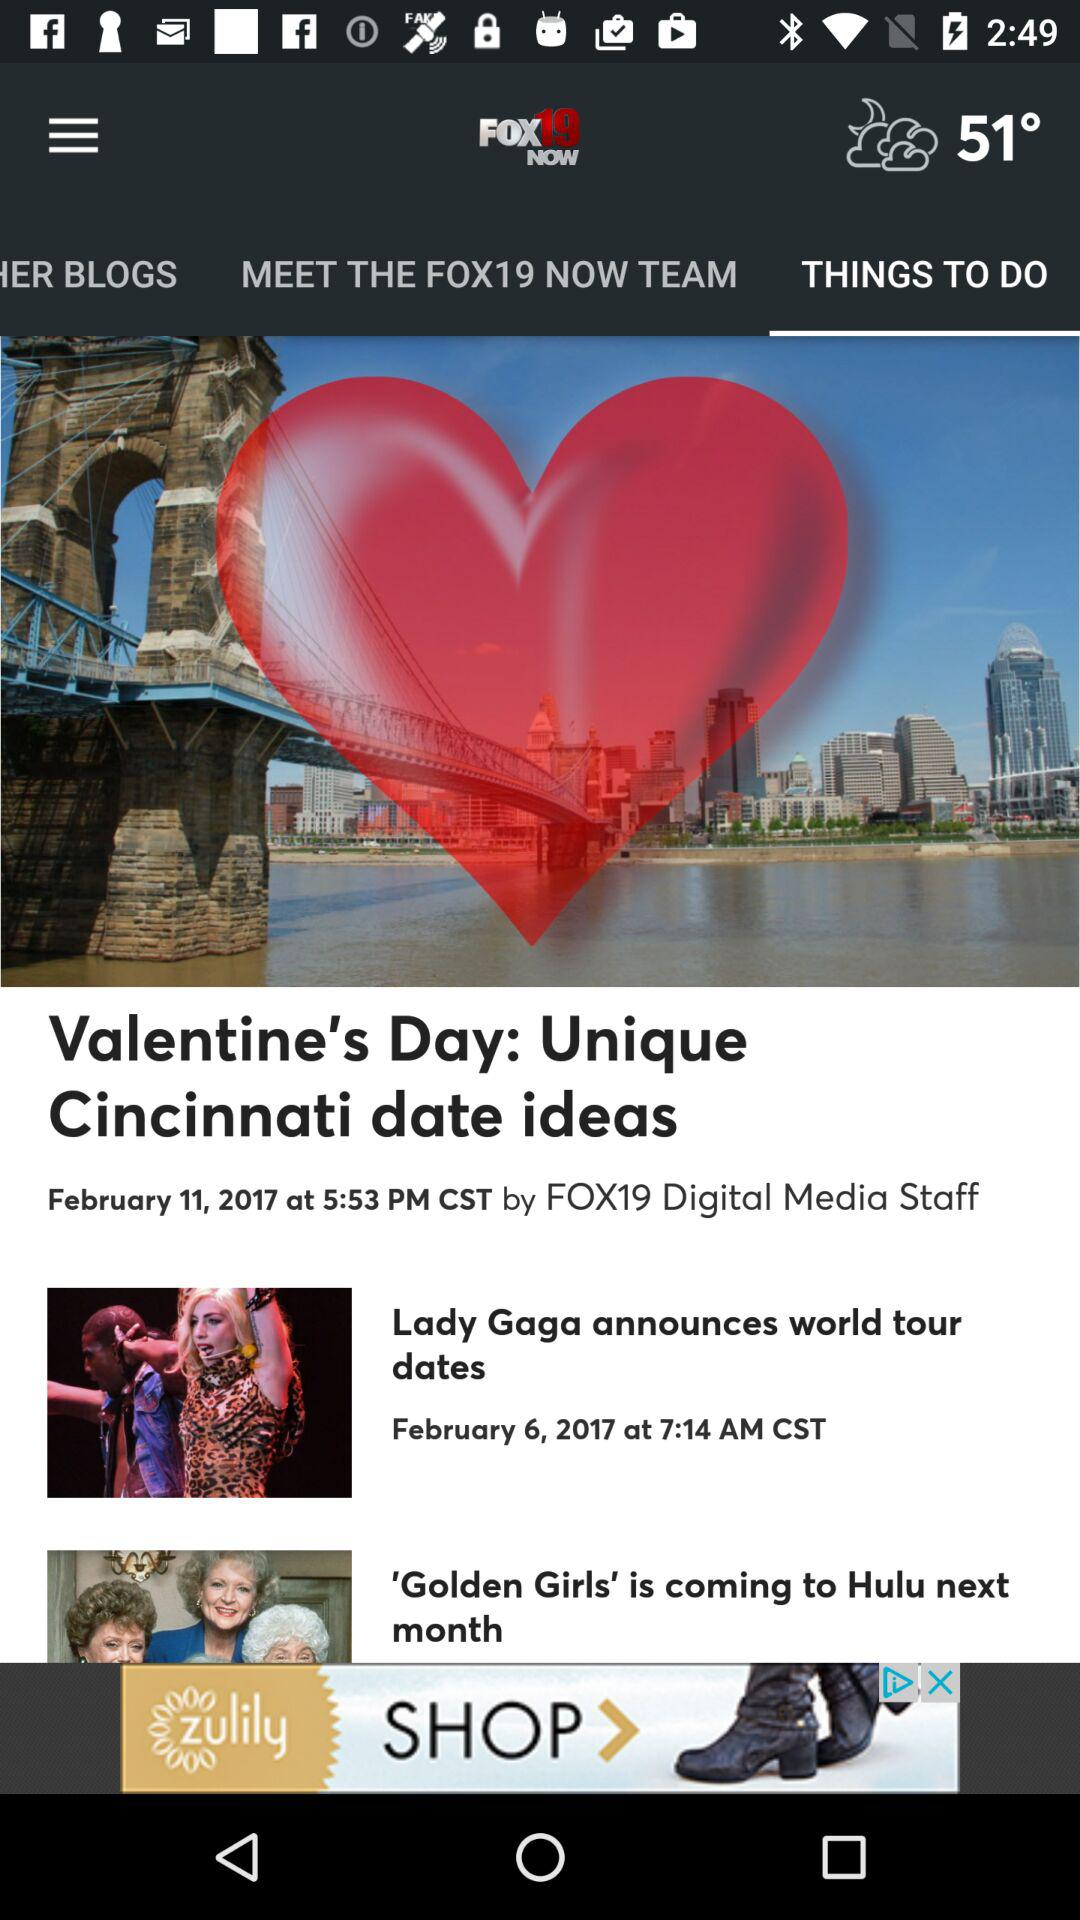What is the temperature? The temperature is 51°. 